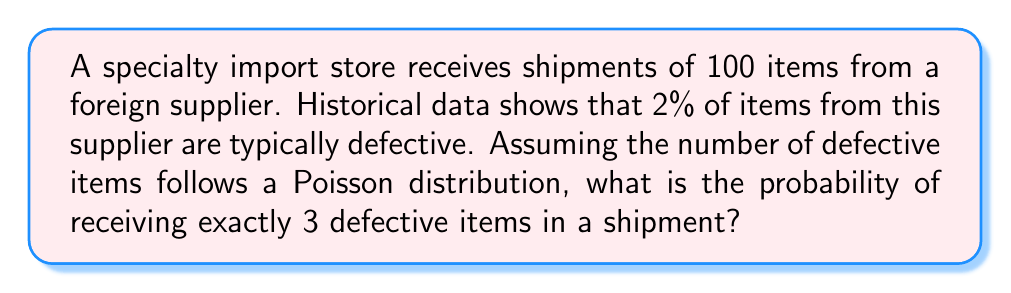Help me with this question. To solve this problem, we'll use the Poisson distribution, which is appropriate for modeling rare events in a fixed interval or space. Let's follow these steps:

1. Identify the parameters:
   - $\lambda$ (average rate of occurrence) = 100 * 0.02 = 2
   - $k$ (number of occurrences we're interested in) = 3

2. Recall the Poisson probability mass function:
   $$P(X = k) = \frac{e^{-\lambda}\lambda^k}{k!}$$

3. Substitute the values:
   $$P(X = 3) = \frac{e^{-2}2^3}{3!}$$

4. Calculate step by step:
   a) $2^3 = 8$
   b) $3! = 3 * 2 * 1 = 6$
   c) $e^{-2} \approx 0.1353$

5. Put it all together:
   $$P(X = 3) = \frac{0.1353 * 8}{6} \approx 0.1804$$

6. Convert to a percentage:
   0.1804 * 100 ≈ 18.04%

Therefore, the probability of receiving exactly 3 defective items in a shipment of 100 is approximately 18.04%.
Answer: 18.04% 